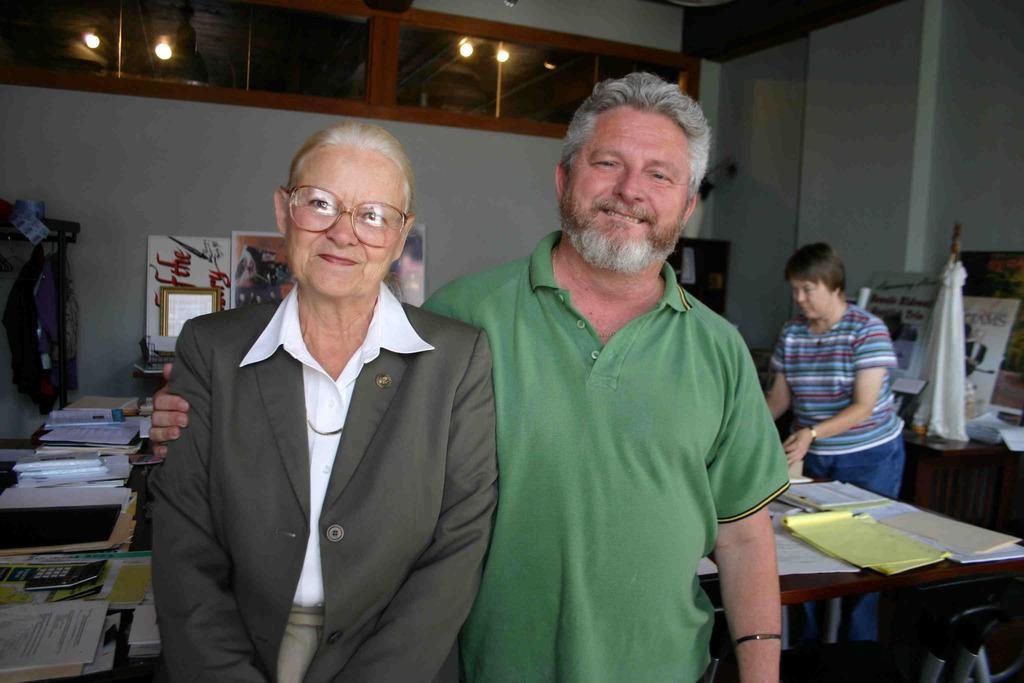Who are the people in the image? There is a woman and a man in the image. Can you describe the woman in the background? There is a woman standing in the background. What objects can be seen on the table in the image? There are papers on a table in the image. What is the board used for in the image? The board's purpose is not specified, but it is present in the image. What type of vegetation is visible in the image? There is a tree in the image. What type of container is present in the image? There is a glass in the image. What is providing light in the image? There is a light in the image. What type of soap is being used to clean the goldfish in the image? There is no soap or goldfish present in the image. 